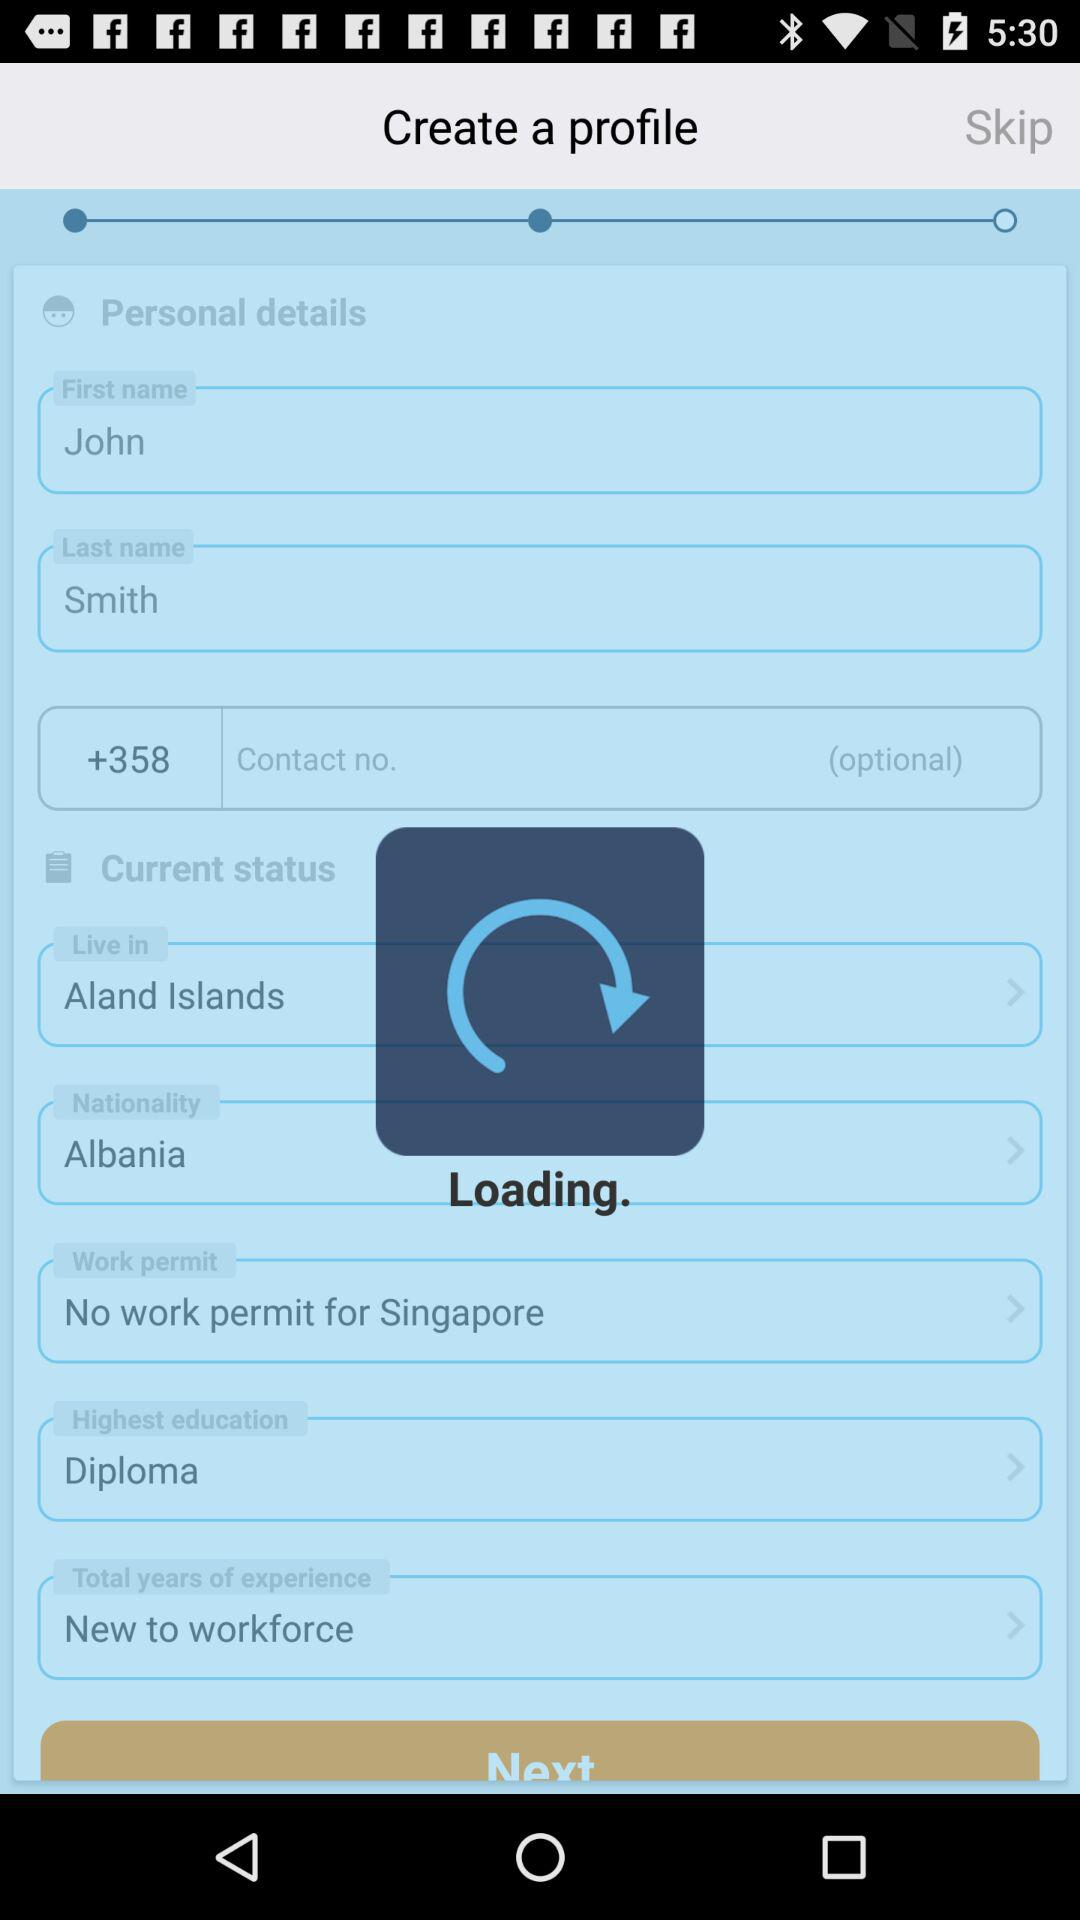What is the last name? The last name is Smith. 